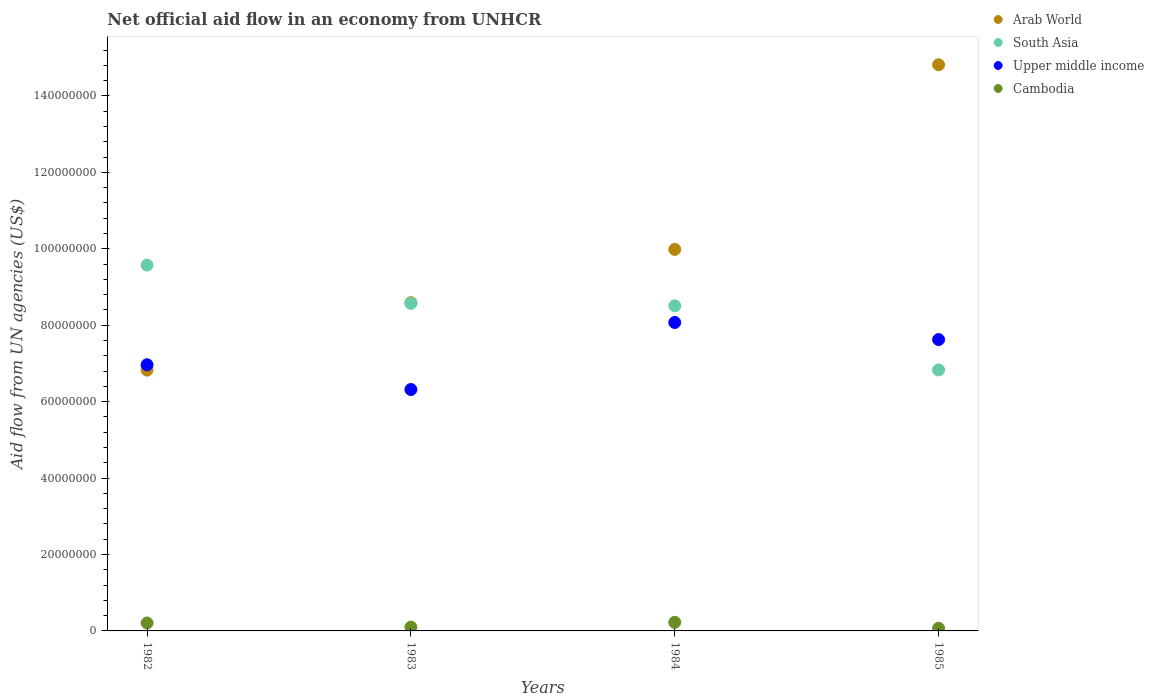What is the net official aid flow in Arab World in 1984?
Your response must be concise. 9.98e+07. Across all years, what is the maximum net official aid flow in Arab World?
Provide a succinct answer. 1.48e+08. Across all years, what is the minimum net official aid flow in Arab World?
Your response must be concise. 6.82e+07. What is the total net official aid flow in South Asia in the graph?
Provide a succinct answer. 3.35e+08. What is the difference between the net official aid flow in South Asia in 1982 and that in 1983?
Offer a terse response. 1.00e+07. What is the difference between the net official aid flow in Arab World in 1984 and the net official aid flow in Cambodia in 1983?
Provide a short and direct response. 9.88e+07. What is the average net official aid flow in Upper middle income per year?
Your answer should be compact. 7.25e+07. In the year 1983, what is the difference between the net official aid flow in Arab World and net official aid flow in South Asia?
Your answer should be very brief. 1.80e+05. In how many years, is the net official aid flow in South Asia greater than 144000000 US$?
Offer a terse response. 0. What is the ratio of the net official aid flow in Arab World in 1982 to that in 1985?
Provide a short and direct response. 0.46. What is the difference between the highest and the second highest net official aid flow in South Asia?
Keep it short and to the point. 1.00e+07. What is the difference between the highest and the lowest net official aid flow in Arab World?
Offer a terse response. 7.99e+07. Is the sum of the net official aid flow in Arab World in 1982 and 1985 greater than the maximum net official aid flow in Cambodia across all years?
Make the answer very short. Yes. Is it the case that in every year, the sum of the net official aid flow in Upper middle income and net official aid flow in South Asia  is greater than the net official aid flow in Arab World?
Provide a succinct answer. No. Is the net official aid flow in Arab World strictly less than the net official aid flow in South Asia over the years?
Make the answer very short. No. How many dotlines are there?
Make the answer very short. 4. Does the graph contain any zero values?
Keep it short and to the point. No. Does the graph contain grids?
Offer a very short reply. No. Where does the legend appear in the graph?
Keep it short and to the point. Top right. How many legend labels are there?
Your answer should be compact. 4. How are the legend labels stacked?
Make the answer very short. Vertical. What is the title of the graph?
Your response must be concise. Net official aid flow in an economy from UNHCR. Does "Cayman Islands" appear as one of the legend labels in the graph?
Keep it short and to the point. No. What is the label or title of the X-axis?
Offer a very short reply. Years. What is the label or title of the Y-axis?
Ensure brevity in your answer.  Aid flow from UN agencies (US$). What is the Aid flow from UN agencies (US$) in Arab World in 1982?
Your answer should be compact. 6.82e+07. What is the Aid flow from UN agencies (US$) of South Asia in 1982?
Your answer should be very brief. 9.57e+07. What is the Aid flow from UN agencies (US$) of Upper middle income in 1982?
Your answer should be compact. 6.97e+07. What is the Aid flow from UN agencies (US$) of Cambodia in 1982?
Keep it short and to the point. 2.08e+06. What is the Aid flow from UN agencies (US$) of Arab World in 1983?
Give a very brief answer. 8.59e+07. What is the Aid flow from UN agencies (US$) in South Asia in 1983?
Give a very brief answer. 8.57e+07. What is the Aid flow from UN agencies (US$) of Upper middle income in 1983?
Keep it short and to the point. 6.32e+07. What is the Aid flow from UN agencies (US$) of Arab World in 1984?
Provide a short and direct response. 9.98e+07. What is the Aid flow from UN agencies (US$) of South Asia in 1984?
Offer a terse response. 8.51e+07. What is the Aid flow from UN agencies (US$) of Upper middle income in 1984?
Keep it short and to the point. 8.07e+07. What is the Aid flow from UN agencies (US$) of Cambodia in 1984?
Offer a terse response. 2.25e+06. What is the Aid flow from UN agencies (US$) in Arab World in 1985?
Ensure brevity in your answer.  1.48e+08. What is the Aid flow from UN agencies (US$) in South Asia in 1985?
Your answer should be very brief. 6.83e+07. What is the Aid flow from UN agencies (US$) of Upper middle income in 1985?
Give a very brief answer. 7.62e+07. What is the Aid flow from UN agencies (US$) in Cambodia in 1985?
Your response must be concise. 7.00e+05. Across all years, what is the maximum Aid flow from UN agencies (US$) in Arab World?
Your answer should be compact. 1.48e+08. Across all years, what is the maximum Aid flow from UN agencies (US$) in South Asia?
Ensure brevity in your answer.  9.57e+07. Across all years, what is the maximum Aid flow from UN agencies (US$) of Upper middle income?
Provide a succinct answer. 8.07e+07. Across all years, what is the maximum Aid flow from UN agencies (US$) of Cambodia?
Your response must be concise. 2.25e+06. Across all years, what is the minimum Aid flow from UN agencies (US$) of Arab World?
Your answer should be compact. 6.82e+07. Across all years, what is the minimum Aid flow from UN agencies (US$) in South Asia?
Ensure brevity in your answer.  6.83e+07. Across all years, what is the minimum Aid flow from UN agencies (US$) in Upper middle income?
Ensure brevity in your answer.  6.32e+07. Across all years, what is the minimum Aid flow from UN agencies (US$) of Cambodia?
Give a very brief answer. 7.00e+05. What is the total Aid flow from UN agencies (US$) of Arab World in the graph?
Keep it short and to the point. 4.02e+08. What is the total Aid flow from UN agencies (US$) of South Asia in the graph?
Keep it short and to the point. 3.35e+08. What is the total Aid flow from UN agencies (US$) of Upper middle income in the graph?
Offer a very short reply. 2.90e+08. What is the total Aid flow from UN agencies (US$) of Cambodia in the graph?
Offer a terse response. 6.03e+06. What is the difference between the Aid flow from UN agencies (US$) of Arab World in 1982 and that in 1983?
Make the answer very short. -1.76e+07. What is the difference between the Aid flow from UN agencies (US$) of South Asia in 1982 and that in 1983?
Ensure brevity in your answer.  1.00e+07. What is the difference between the Aid flow from UN agencies (US$) in Upper middle income in 1982 and that in 1983?
Give a very brief answer. 6.48e+06. What is the difference between the Aid flow from UN agencies (US$) in Cambodia in 1982 and that in 1983?
Your answer should be very brief. 1.08e+06. What is the difference between the Aid flow from UN agencies (US$) in Arab World in 1982 and that in 1984?
Your response must be concise. -3.16e+07. What is the difference between the Aid flow from UN agencies (US$) of South Asia in 1982 and that in 1984?
Offer a very short reply. 1.07e+07. What is the difference between the Aid flow from UN agencies (US$) in Upper middle income in 1982 and that in 1984?
Offer a very short reply. -1.11e+07. What is the difference between the Aid flow from UN agencies (US$) in Arab World in 1982 and that in 1985?
Your answer should be very brief. -7.99e+07. What is the difference between the Aid flow from UN agencies (US$) of South Asia in 1982 and that in 1985?
Ensure brevity in your answer.  2.74e+07. What is the difference between the Aid flow from UN agencies (US$) of Upper middle income in 1982 and that in 1985?
Provide a succinct answer. -6.59e+06. What is the difference between the Aid flow from UN agencies (US$) in Cambodia in 1982 and that in 1985?
Provide a succinct answer. 1.38e+06. What is the difference between the Aid flow from UN agencies (US$) of Arab World in 1983 and that in 1984?
Your answer should be compact. -1.39e+07. What is the difference between the Aid flow from UN agencies (US$) of South Asia in 1983 and that in 1984?
Your response must be concise. 6.40e+05. What is the difference between the Aid flow from UN agencies (US$) in Upper middle income in 1983 and that in 1984?
Provide a short and direct response. -1.75e+07. What is the difference between the Aid flow from UN agencies (US$) in Cambodia in 1983 and that in 1984?
Provide a short and direct response. -1.25e+06. What is the difference between the Aid flow from UN agencies (US$) in Arab World in 1983 and that in 1985?
Provide a short and direct response. -6.23e+07. What is the difference between the Aid flow from UN agencies (US$) in South Asia in 1983 and that in 1985?
Give a very brief answer. 1.74e+07. What is the difference between the Aid flow from UN agencies (US$) of Upper middle income in 1983 and that in 1985?
Offer a terse response. -1.31e+07. What is the difference between the Aid flow from UN agencies (US$) in Arab World in 1984 and that in 1985?
Offer a very short reply. -4.83e+07. What is the difference between the Aid flow from UN agencies (US$) in South Asia in 1984 and that in 1985?
Give a very brief answer. 1.68e+07. What is the difference between the Aid flow from UN agencies (US$) of Upper middle income in 1984 and that in 1985?
Offer a very short reply. 4.47e+06. What is the difference between the Aid flow from UN agencies (US$) in Cambodia in 1984 and that in 1985?
Make the answer very short. 1.55e+06. What is the difference between the Aid flow from UN agencies (US$) of Arab World in 1982 and the Aid flow from UN agencies (US$) of South Asia in 1983?
Offer a terse response. -1.75e+07. What is the difference between the Aid flow from UN agencies (US$) in Arab World in 1982 and the Aid flow from UN agencies (US$) in Upper middle income in 1983?
Offer a very short reply. 5.07e+06. What is the difference between the Aid flow from UN agencies (US$) of Arab World in 1982 and the Aid flow from UN agencies (US$) of Cambodia in 1983?
Offer a terse response. 6.72e+07. What is the difference between the Aid flow from UN agencies (US$) of South Asia in 1982 and the Aid flow from UN agencies (US$) of Upper middle income in 1983?
Provide a short and direct response. 3.26e+07. What is the difference between the Aid flow from UN agencies (US$) of South Asia in 1982 and the Aid flow from UN agencies (US$) of Cambodia in 1983?
Keep it short and to the point. 9.47e+07. What is the difference between the Aid flow from UN agencies (US$) of Upper middle income in 1982 and the Aid flow from UN agencies (US$) of Cambodia in 1983?
Your response must be concise. 6.87e+07. What is the difference between the Aid flow from UN agencies (US$) in Arab World in 1982 and the Aid flow from UN agencies (US$) in South Asia in 1984?
Ensure brevity in your answer.  -1.68e+07. What is the difference between the Aid flow from UN agencies (US$) of Arab World in 1982 and the Aid flow from UN agencies (US$) of Upper middle income in 1984?
Your answer should be compact. -1.25e+07. What is the difference between the Aid flow from UN agencies (US$) in Arab World in 1982 and the Aid flow from UN agencies (US$) in Cambodia in 1984?
Your answer should be compact. 6.60e+07. What is the difference between the Aid flow from UN agencies (US$) in South Asia in 1982 and the Aid flow from UN agencies (US$) in Upper middle income in 1984?
Ensure brevity in your answer.  1.50e+07. What is the difference between the Aid flow from UN agencies (US$) in South Asia in 1982 and the Aid flow from UN agencies (US$) in Cambodia in 1984?
Your response must be concise. 9.35e+07. What is the difference between the Aid flow from UN agencies (US$) of Upper middle income in 1982 and the Aid flow from UN agencies (US$) of Cambodia in 1984?
Provide a short and direct response. 6.74e+07. What is the difference between the Aid flow from UN agencies (US$) in Arab World in 1982 and the Aid flow from UN agencies (US$) in South Asia in 1985?
Give a very brief answer. -5.00e+04. What is the difference between the Aid flow from UN agencies (US$) in Arab World in 1982 and the Aid flow from UN agencies (US$) in Upper middle income in 1985?
Offer a terse response. -8.00e+06. What is the difference between the Aid flow from UN agencies (US$) of Arab World in 1982 and the Aid flow from UN agencies (US$) of Cambodia in 1985?
Your answer should be compact. 6.76e+07. What is the difference between the Aid flow from UN agencies (US$) of South Asia in 1982 and the Aid flow from UN agencies (US$) of Upper middle income in 1985?
Ensure brevity in your answer.  1.95e+07. What is the difference between the Aid flow from UN agencies (US$) in South Asia in 1982 and the Aid flow from UN agencies (US$) in Cambodia in 1985?
Your answer should be compact. 9.50e+07. What is the difference between the Aid flow from UN agencies (US$) of Upper middle income in 1982 and the Aid flow from UN agencies (US$) of Cambodia in 1985?
Ensure brevity in your answer.  6.90e+07. What is the difference between the Aid flow from UN agencies (US$) of Arab World in 1983 and the Aid flow from UN agencies (US$) of South Asia in 1984?
Provide a succinct answer. 8.20e+05. What is the difference between the Aid flow from UN agencies (US$) in Arab World in 1983 and the Aid flow from UN agencies (US$) in Upper middle income in 1984?
Offer a very short reply. 5.18e+06. What is the difference between the Aid flow from UN agencies (US$) in Arab World in 1983 and the Aid flow from UN agencies (US$) in Cambodia in 1984?
Make the answer very short. 8.36e+07. What is the difference between the Aid flow from UN agencies (US$) in South Asia in 1983 and the Aid flow from UN agencies (US$) in Cambodia in 1984?
Provide a succinct answer. 8.35e+07. What is the difference between the Aid flow from UN agencies (US$) in Upper middle income in 1983 and the Aid flow from UN agencies (US$) in Cambodia in 1984?
Keep it short and to the point. 6.09e+07. What is the difference between the Aid flow from UN agencies (US$) of Arab World in 1983 and the Aid flow from UN agencies (US$) of South Asia in 1985?
Offer a very short reply. 1.76e+07. What is the difference between the Aid flow from UN agencies (US$) in Arab World in 1983 and the Aid flow from UN agencies (US$) in Upper middle income in 1985?
Your answer should be compact. 9.65e+06. What is the difference between the Aid flow from UN agencies (US$) in Arab World in 1983 and the Aid flow from UN agencies (US$) in Cambodia in 1985?
Ensure brevity in your answer.  8.52e+07. What is the difference between the Aid flow from UN agencies (US$) in South Asia in 1983 and the Aid flow from UN agencies (US$) in Upper middle income in 1985?
Provide a short and direct response. 9.47e+06. What is the difference between the Aid flow from UN agencies (US$) of South Asia in 1983 and the Aid flow from UN agencies (US$) of Cambodia in 1985?
Offer a terse response. 8.50e+07. What is the difference between the Aid flow from UN agencies (US$) in Upper middle income in 1983 and the Aid flow from UN agencies (US$) in Cambodia in 1985?
Your response must be concise. 6.25e+07. What is the difference between the Aid flow from UN agencies (US$) in Arab World in 1984 and the Aid flow from UN agencies (US$) in South Asia in 1985?
Keep it short and to the point. 3.15e+07. What is the difference between the Aid flow from UN agencies (US$) in Arab World in 1984 and the Aid flow from UN agencies (US$) in Upper middle income in 1985?
Make the answer very short. 2.36e+07. What is the difference between the Aid flow from UN agencies (US$) of Arab World in 1984 and the Aid flow from UN agencies (US$) of Cambodia in 1985?
Your answer should be compact. 9.91e+07. What is the difference between the Aid flow from UN agencies (US$) in South Asia in 1984 and the Aid flow from UN agencies (US$) in Upper middle income in 1985?
Give a very brief answer. 8.83e+06. What is the difference between the Aid flow from UN agencies (US$) of South Asia in 1984 and the Aid flow from UN agencies (US$) of Cambodia in 1985?
Provide a short and direct response. 8.44e+07. What is the difference between the Aid flow from UN agencies (US$) in Upper middle income in 1984 and the Aid flow from UN agencies (US$) in Cambodia in 1985?
Provide a short and direct response. 8.00e+07. What is the average Aid flow from UN agencies (US$) in Arab World per year?
Your response must be concise. 1.01e+08. What is the average Aid flow from UN agencies (US$) in South Asia per year?
Your answer should be compact. 8.37e+07. What is the average Aid flow from UN agencies (US$) in Upper middle income per year?
Give a very brief answer. 7.25e+07. What is the average Aid flow from UN agencies (US$) in Cambodia per year?
Ensure brevity in your answer.  1.51e+06. In the year 1982, what is the difference between the Aid flow from UN agencies (US$) of Arab World and Aid flow from UN agencies (US$) of South Asia?
Give a very brief answer. -2.75e+07. In the year 1982, what is the difference between the Aid flow from UN agencies (US$) in Arab World and Aid flow from UN agencies (US$) in Upper middle income?
Keep it short and to the point. -1.41e+06. In the year 1982, what is the difference between the Aid flow from UN agencies (US$) in Arab World and Aid flow from UN agencies (US$) in Cambodia?
Your answer should be compact. 6.62e+07. In the year 1982, what is the difference between the Aid flow from UN agencies (US$) of South Asia and Aid flow from UN agencies (US$) of Upper middle income?
Offer a terse response. 2.61e+07. In the year 1982, what is the difference between the Aid flow from UN agencies (US$) in South Asia and Aid flow from UN agencies (US$) in Cambodia?
Offer a terse response. 9.37e+07. In the year 1982, what is the difference between the Aid flow from UN agencies (US$) in Upper middle income and Aid flow from UN agencies (US$) in Cambodia?
Provide a short and direct response. 6.76e+07. In the year 1983, what is the difference between the Aid flow from UN agencies (US$) of Arab World and Aid flow from UN agencies (US$) of South Asia?
Your response must be concise. 1.80e+05. In the year 1983, what is the difference between the Aid flow from UN agencies (US$) in Arab World and Aid flow from UN agencies (US$) in Upper middle income?
Give a very brief answer. 2.27e+07. In the year 1983, what is the difference between the Aid flow from UN agencies (US$) of Arab World and Aid flow from UN agencies (US$) of Cambodia?
Make the answer very short. 8.49e+07. In the year 1983, what is the difference between the Aid flow from UN agencies (US$) of South Asia and Aid flow from UN agencies (US$) of Upper middle income?
Ensure brevity in your answer.  2.25e+07. In the year 1983, what is the difference between the Aid flow from UN agencies (US$) of South Asia and Aid flow from UN agencies (US$) of Cambodia?
Your answer should be compact. 8.47e+07. In the year 1983, what is the difference between the Aid flow from UN agencies (US$) of Upper middle income and Aid flow from UN agencies (US$) of Cambodia?
Your response must be concise. 6.22e+07. In the year 1984, what is the difference between the Aid flow from UN agencies (US$) in Arab World and Aid flow from UN agencies (US$) in South Asia?
Offer a terse response. 1.48e+07. In the year 1984, what is the difference between the Aid flow from UN agencies (US$) in Arab World and Aid flow from UN agencies (US$) in Upper middle income?
Your answer should be very brief. 1.91e+07. In the year 1984, what is the difference between the Aid flow from UN agencies (US$) of Arab World and Aid flow from UN agencies (US$) of Cambodia?
Offer a very short reply. 9.76e+07. In the year 1984, what is the difference between the Aid flow from UN agencies (US$) in South Asia and Aid flow from UN agencies (US$) in Upper middle income?
Provide a short and direct response. 4.36e+06. In the year 1984, what is the difference between the Aid flow from UN agencies (US$) in South Asia and Aid flow from UN agencies (US$) in Cambodia?
Provide a succinct answer. 8.28e+07. In the year 1984, what is the difference between the Aid flow from UN agencies (US$) of Upper middle income and Aid flow from UN agencies (US$) of Cambodia?
Provide a succinct answer. 7.85e+07. In the year 1985, what is the difference between the Aid flow from UN agencies (US$) of Arab World and Aid flow from UN agencies (US$) of South Asia?
Your answer should be compact. 7.99e+07. In the year 1985, what is the difference between the Aid flow from UN agencies (US$) of Arab World and Aid flow from UN agencies (US$) of Upper middle income?
Your answer should be compact. 7.19e+07. In the year 1985, what is the difference between the Aid flow from UN agencies (US$) of Arab World and Aid flow from UN agencies (US$) of Cambodia?
Your answer should be compact. 1.47e+08. In the year 1985, what is the difference between the Aid flow from UN agencies (US$) in South Asia and Aid flow from UN agencies (US$) in Upper middle income?
Offer a terse response. -7.95e+06. In the year 1985, what is the difference between the Aid flow from UN agencies (US$) of South Asia and Aid flow from UN agencies (US$) of Cambodia?
Provide a succinct answer. 6.76e+07. In the year 1985, what is the difference between the Aid flow from UN agencies (US$) in Upper middle income and Aid flow from UN agencies (US$) in Cambodia?
Your answer should be very brief. 7.56e+07. What is the ratio of the Aid flow from UN agencies (US$) in Arab World in 1982 to that in 1983?
Offer a terse response. 0.79. What is the ratio of the Aid flow from UN agencies (US$) in South Asia in 1982 to that in 1983?
Your answer should be very brief. 1.12. What is the ratio of the Aid flow from UN agencies (US$) in Upper middle income in 1982 to that in 1983?
Provide a short and direct response. 1.1. What is the ratio of the Aid flow from UN agencies (US$) in Cambodia in 1982 to that in 1983?
Keep it short and to the point. 2.08. What is the ratio of the Aid flow from UN agencies (US$) in Arab World in 1982 to that in 1984?
Make the answer very short. 0.68. What is the ratio of the Aid flow from UN agencies (US$) of South Asia in 1982 to that in 1984?
Provide a succinct answer. 1.13. What is the ratio of the Aid flow from UN agencies (US$) in Upper middle income in 1982 to that in 1984?
Provide a succinct answer. 0.86. What is the ratio of the Aid flow from UN agencies (US$) of Cambodia in 1982 to that in 1984?
Your answer should be very brief. 0.92. What is the ratio of the Aid flow from UN agencies (US$) in Arab World in 1982 to that in 1985?
Your answer should be compact. 0.46. What is the ratio of the Aid flow from UN agencies (US$) in South Asia in 1982 to that in 1985?
Make the answer very short. 1.4. What is the ratio of the Aid flow from UN agencies (US$) of Upper middle income in 1982 to that in 1985?
Your response must be concise. 0.91. What is the ratio of the Aid flow from UN agencies (US$) of Cambodia in 1982 to that in 1985?
Keep it short and to the point. 2.97. What is the ratio of the Aid flow from UN agencies (US$) in Arab World in 1983 to that in 1984?
Keep it short and to the point. 0.86. What is the ratio of the Aid flow from UN agencies (US$) of South Asia in 1983 to that in 1984?
Ensure brevity in your answer.  1.01. What is the ratio of the Aid flow from UN agencies (US$) of Upper middle income in 1983 to that in 1984?
Offer a very short reply. 0.78. What is the ratio of the Aid flow from UN agencies (US$) in Cambodia in 1983 to that in 1984?
Provide a succinct answer. 0.44. What is the ratio of the Aid flow from UN agencies (US$) in Arab World in 1983 to that in 1985?
Provide a succinct answer. 0.58. What is the ratio of the Aid flow from UN agencies (US$) in South Asia in 1983 to that in 1985?
Make the answer very short. 1.26. What is the ratio of the Aid flow from UN agencies (US$) in Upper middle income in 1983 to that in 1985?
Your answer should be very brief. 0.83. What is the ratio of the Aid flow from UN agencies (US$) of Cambodia in 1983 to that in 1985?
Provide a succinct answer. 1.43. What is the ratio of the Aid flow from UN agencies (US$) of Arab World in 1984 to that in 1985?
Ensure brevity in your answer.  0.67. What is the ratio of the Aid flow from UN agencies (US$) of South Asia in 1984 to that in 1985?
Offer a terse response. 1.25. What is the ratio of the Aid flow from UN agencies (US$) in Upper middle income in 1984 to that in 1985?
Offer a very short reply. 1.06. What is the ratio of the Aid flow from UN agencies (US$) of Cambodia in 1984 to that in 1985?
Offer a very short reply. 3.21. What is the difference between the highest and the second highest Aid flow from UN agencies (US$) of Arab World?
Ensure brevity in your answer.  4.83e+07. What is the difference between the highest and the second highest Aid flow from UN agencies (US$) of South Asia?
Make the answer very short. 1.00e+07. What is the difference between the highest and the second highest Aid flow from UN agencies (US$) in Upper middle income?
Provide a short and direct response. 4.47e+06. What is the difference between the highest and the lowest Aid flow from UN agencies (US$) of Arab World?
Give a very brief answer. 7.99e+07. What is the difference between the highest and the lowest Aid flow from UN agencies (US$) in South Asia?
Your answer should be compact. 2.74e+07. What is the difference between the highest and the lowest Aid flow from UN agencies (US$) in Upper middle income?
Offer a very short reply. 1.75e+07. What is the difference between the highest and the lowest Aid flow from UN agencies (US$) in Cambodia?
Your response must be concise. 1.55e+06. 